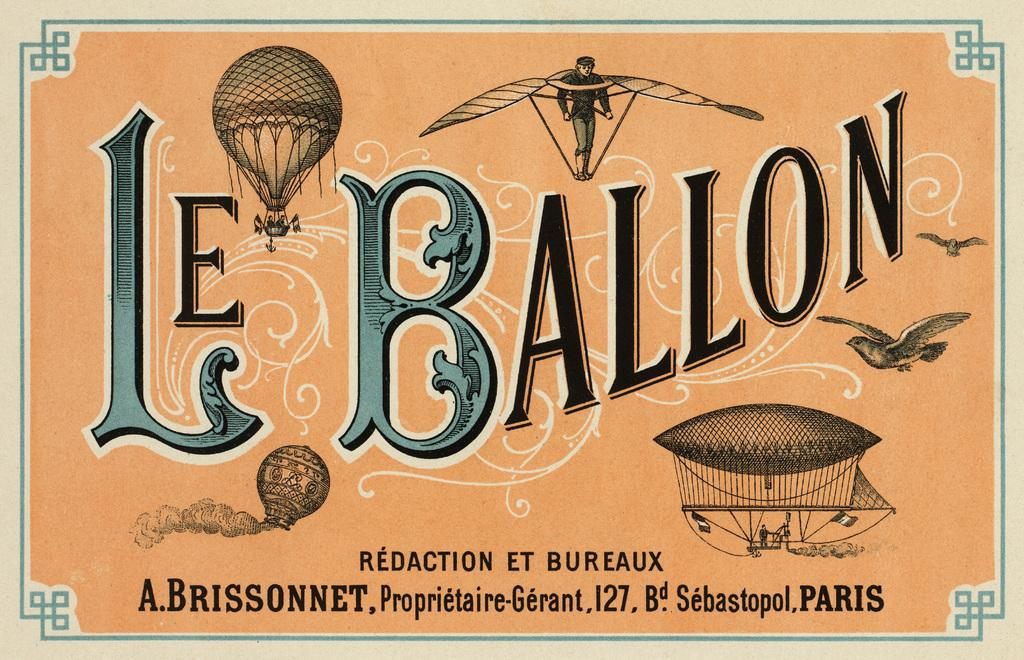<image>
Provide a brief description of the given image. An old flyer for Le Ballon Redaction Et Bureaux in Paris. 